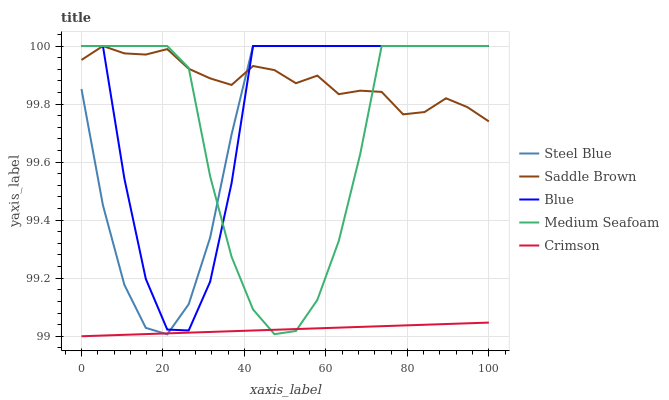Does Crimson have the minimum area under the curve?
Answer yes or no. Yes. Does Saddle Brown have the maximum area under the curve?
Answer yes or no. Yes. Does Medium Seafoam have the minimum area under the curve?
Answer yes or no. No. Does Medium Seafoam have the maximum area under the curve?
Answer yes or no. No. Is Crimson the smoothest?
Answer yes or no. Yes. Is Blue the roughest?
Answer yes or no. Yes. Is Medium Seafoam the smoothest?
Answer yes or no. No. Is Medium Seafoam the roughest?
Answer yes or no. No. Does Crimson have the lowest value?
Answer yes or no. Yes. Does Medium Seafoam have the lowest value?
Answer yes or no. No. Does Saddle Brown have the highest value?
Answer yes or no. Yes. Does Crimson have the highest value?
Answer yes or no. No. Is Crimson less than Saddle Brown?
Answer yes or no. Yes. Is Blue greater than Crimson?
Answer yes or no. Yes. Does Crimson intersect Medium Seafoam?
Answer yes or no. Yes. Is Crimson less than Medium Seafoam?
Answer yes or no. No. Is Crimson greater than Medium Seafoam?
Answer yes or no. No. Does Crimson intersect Saddle Brown?
Answer yes or no. No. 